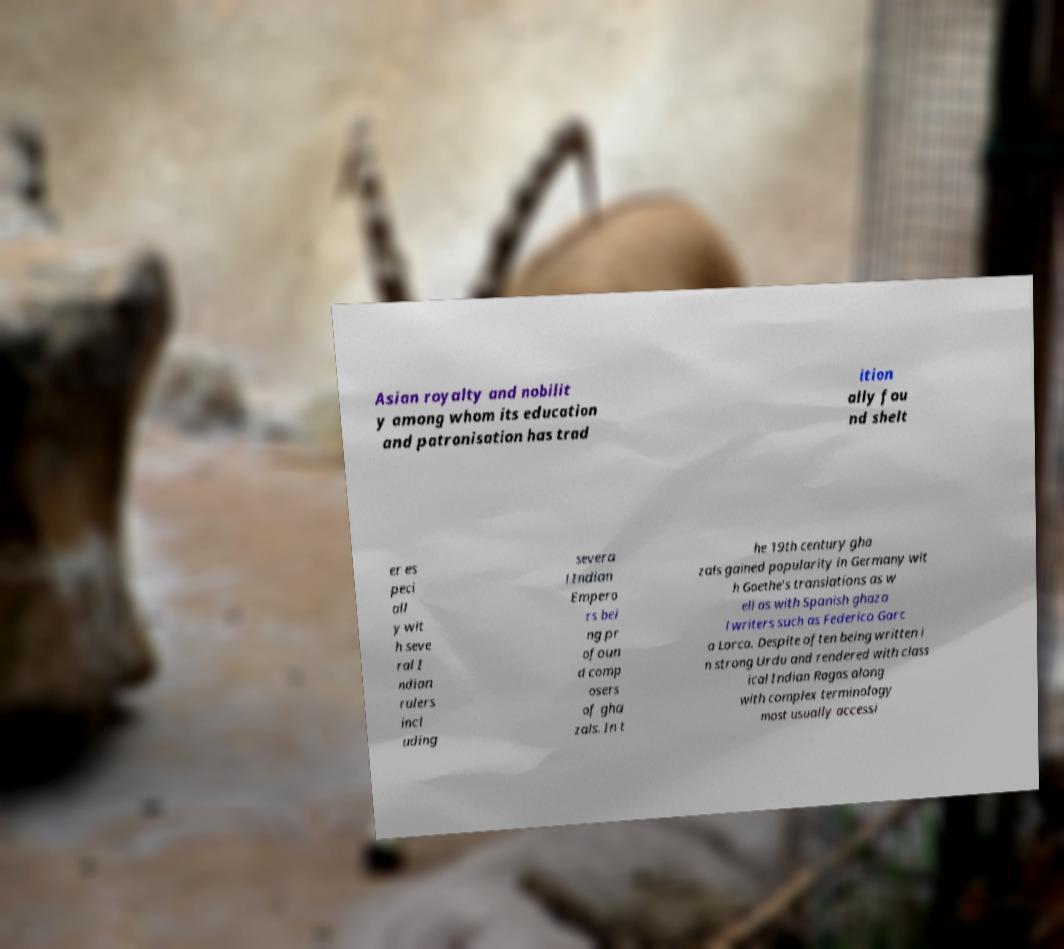I need the written content from this picture converted into text. Can you do that? Asian royalty and nobilit y among whom its education and patronisation has trad ition ally fou nd shelt er es peci all y wit h seve ral I ndian rulers incl uding severa l Indian Empero rs bei ng pr ofoun d comp osers of gha zals. In t he 19th century gha zals gained popularity in Germany wit h Goethe's translations as w ell as with Spanish ghaza l writers such as Federico Garc a Lorca. Despite often being written i n strong Urdu and rendered with class ical Indian Ragas along with complex terminology most usually accessi 